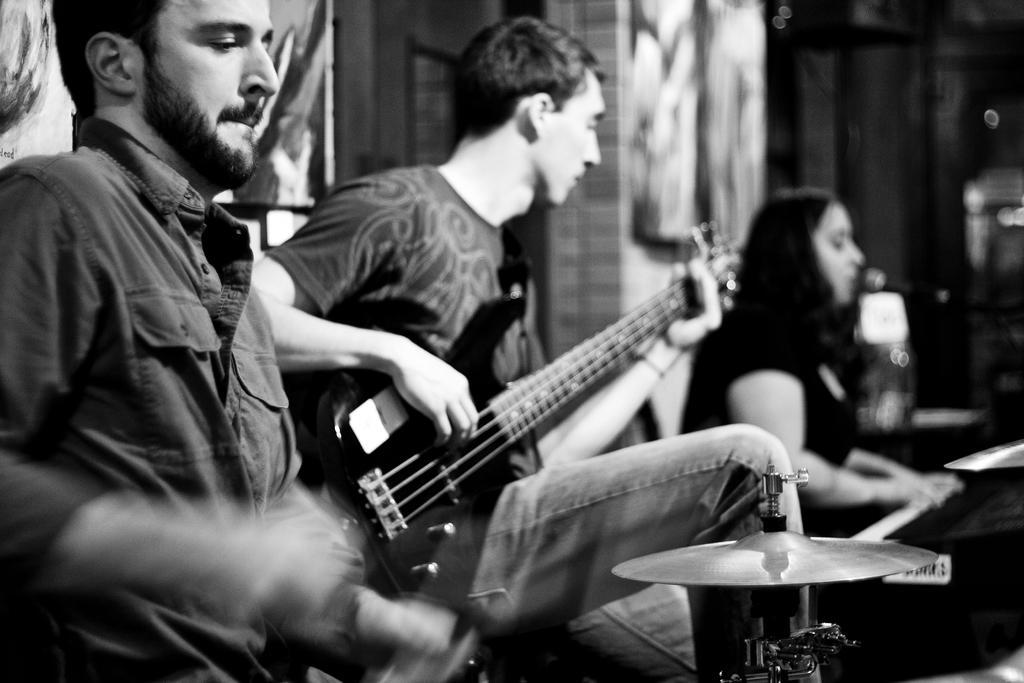How would you summarize this image in a sentence or two? Here we can see a person on the left side. There is a person sitting here and he is playing a guitar. There is a woman on the right side. 